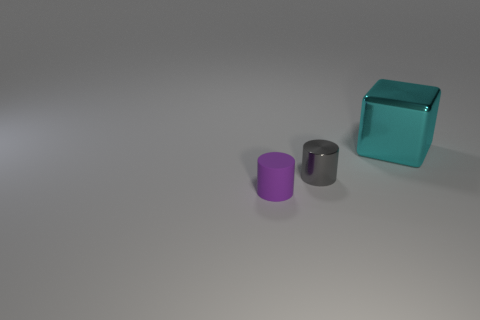Subtract all purple cylinders. How many cylinders are left? 1 Subtract all cylinders. How many objects are left? 1 Add 2 tiny red rubber spheres. How many objects exist? 5 Subtract 2 cylinders. How many cylinders are left? 0 Subtract all yellow cylinders. Subtract all red balls. How many cylinders are left? 2 Subtract all brown blocks. How many gray cylinders are left? 1 Subtract all big cyan metal things. Subtract all gray metallic cylinders. How many objects are left? 1 Add 2 small gray shiny cylinders. How many small gray shiny cylinders are left? 3 Add 2 small purple rubber cylinders. How many small purple rubber cylinders exist? 3 Subtract 0 yellow cylinders. How many objects are left? 3 